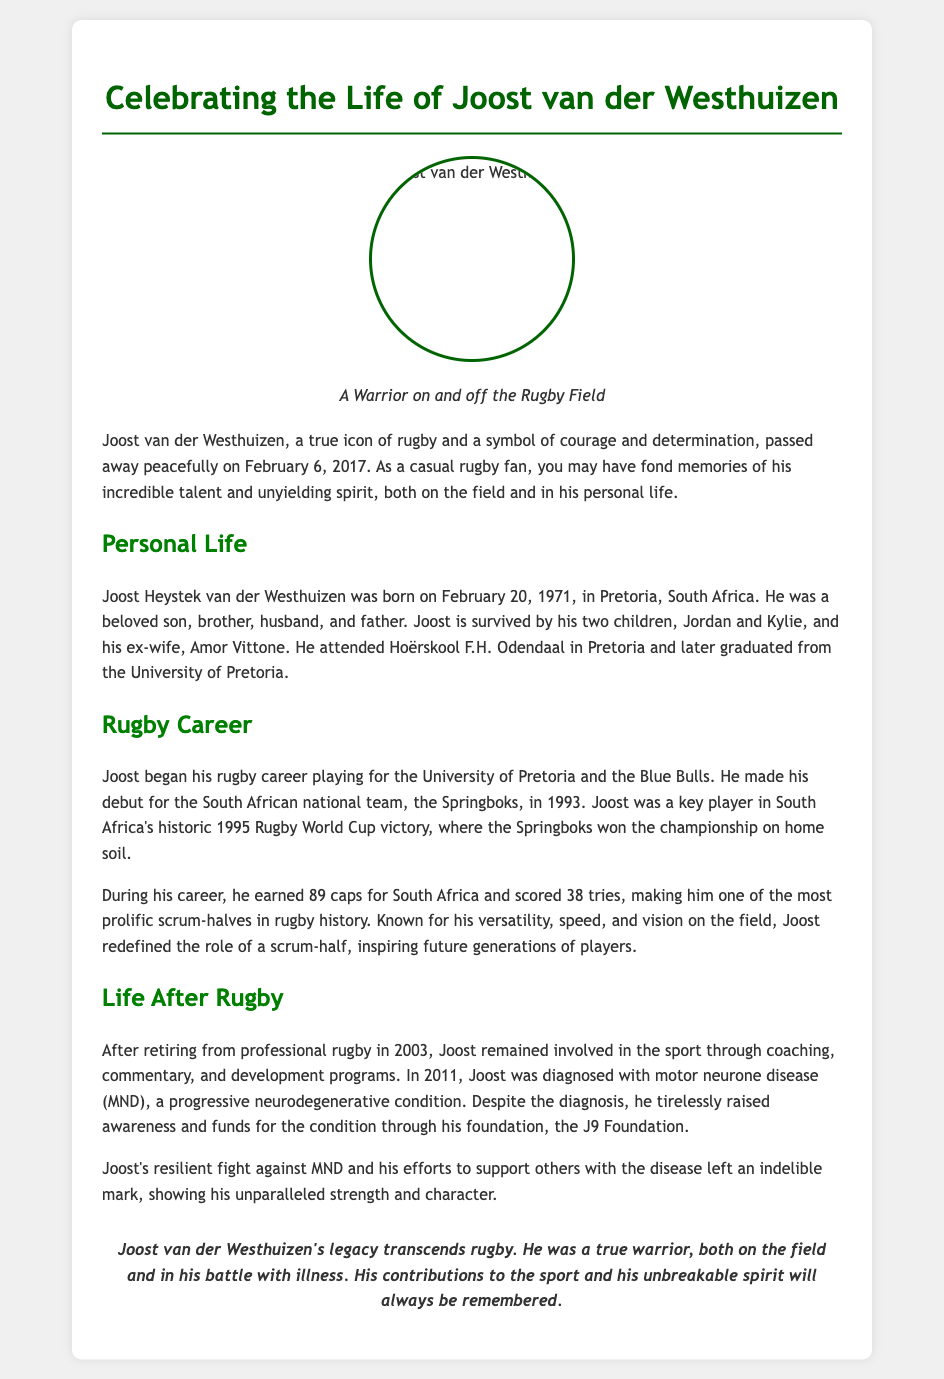What date did Joost van der Westhuizen pass away? The document states that Joost van der Westhuizen passed away on February 6, 2017.
Answer: February 6, 2017 What position did Joost van der Westhuizen play? The document references Joost as a scrum-half, highlighting his significance in that position.
Answer: Scrum-half How many tries did Joost score during his career? The document mentions that Joost scored 38 tries for the South African national team.
Answer: 38 tries Which Rugby World Cup did Joost van der Westhuizen help win? The document indicates that he was a key player in South Africa's historic 1995 Rugby World Cup victory.
Answer: 1995 Rugby World Cup What disease was Joost diagnosed with in 2011? The document states that Joost was diagnosed with motor neurone disease (MND) in 2011.
Answer: Motor neurone disease (MND) How many caps did Joost earn for South Africa? The document notes that Joost earned 89 caps for the South African national team.
Answer: 89 caps What was the name of Joost's foundation? The document mentions the J9 Foundation as the organization Joost created to raise awareness and funds for motor neurone disease.
Answer: J9 Foundation What legacy did Joost van der Westhuizen leave behind? The document emphasizes that Joost's legacy transcends rugby, reflecting on his contributions to the sport and unbreakable spirit.
Answer: Legacy transcends rugby What educational institutions did Joost attend? The document lists Hoërskool F.H. Odendaal and the University of Pretoria as the schools Joost attended.
Answer: Hoërskool F.H. Odendaal, University of Pretoria 